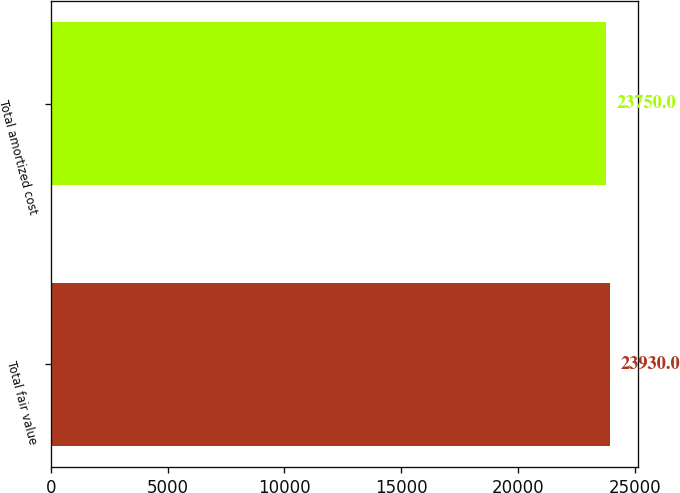Convert chart. <chart><loc_0><loc_0><loc_500><loc_500><bar_chart><fcel>Total fair value<fcel>Total amortized cost<nl><fcel>23930<fcel>23750<nl></chart> 